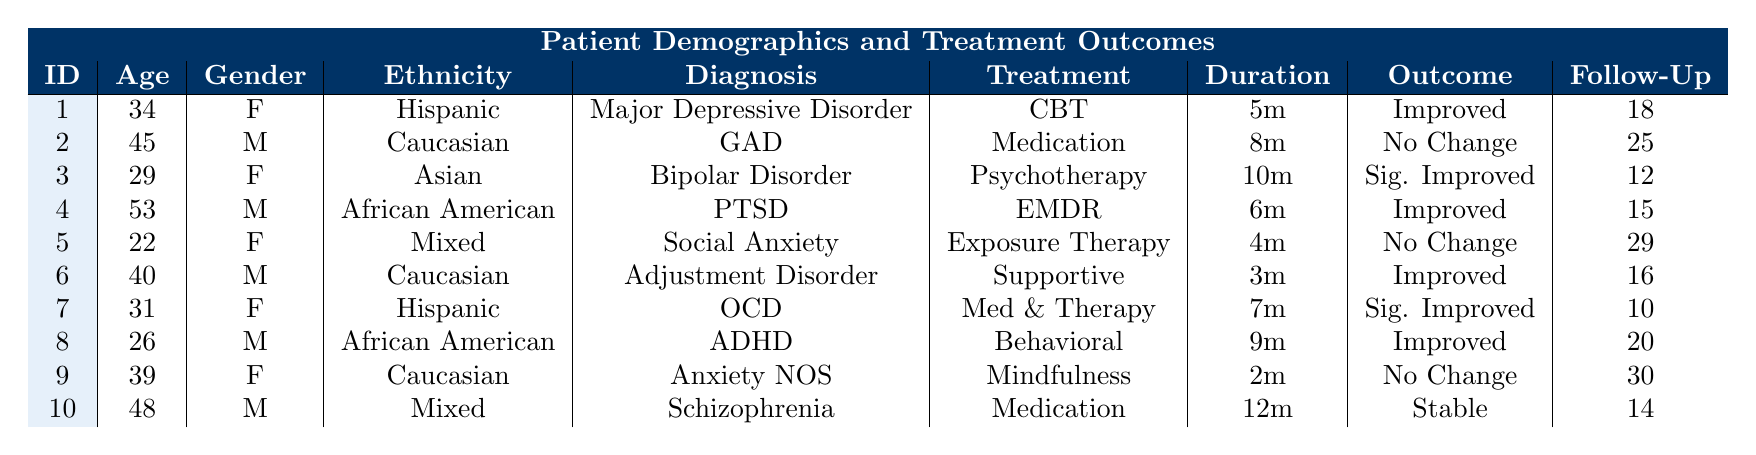What is the age of Patient 5? Patient 5's row shows that the age is listed as 22.
Answer: 22 How many patients received Medication Management as their treatment type? From the table, Patient 2 and Patient 10 are the only two patients who received Medication Management, so the total is 2.
Answer: 2 What was the Outcome of the patient diagnosed with Obsessive-Compulsive Disorder? Looking at the row for Patient 7, the Outcome is listed as "Significantly Improved."
Answer: Significantly Improved What is the Follow-Up Score for the patient who had the longest treatment duration? Patient 10, who received treatment for 12 months (longest duration), has a Follow-Up Score of 14.
Answer: 14 Which treatment types led to "Improved" outcomes? Reviewing the table, treatment types CBT (Patient 1), EMDR (Patient 4), Supportive Therapy (Patient 6), and Behavioral Therapy (Patient 8) resulted in “Improved” outcomes.
Answer: CBT, EMDR, Supportive Therapy, Behavioral Therapy Is there any patient who experienced "No Change" in their treatment outcome? Patients 2, 5, and 9 all reported "No Change" in their outcomes. Therefore, the answer is yes.
Answer: Yes What is the average Follow-Up Score of patients who had "No Change" in their treatment outcome? The Follow-Up Scores for Patients 2, 5, and 9 are 25, 29, and 30 respectively. Summing these gives 25 + 29 + 30 = 84. Dividing by 3 (the number of patients) gives an average of 28.
Answer: 28 How many patients aged 30 or younger improved their condition? Looking at the table, Patients 1 (34), 3 (29), 5 (22), and 7 (31) had improved outcomes. However, only Patient 3 and Patient 5 are aged 30 or younger. Thus, there are 2 patients who improved.
Answer: 2 Identify the demographic group with the highest incidence of "Significantly Improved" outcomes. Patient 3 and Patient 7 both showed "Significantly Improved" outcomes, where Patient 3 is Asian and Patient 7 is Hispanic. Asian and Hispanic demographics both fall in the same incidence.
Answer: Asian and Hispanic What is the overall percentage of patients who experienced "Improved" outcomes out of the total number of patients in the table? There are 10 patients total, and 5 experienced "Improved" outcomes (Patients 1, 3, 4, 6, and 8). Thus, the percentage is (5/10) * 100 = 50%.
Answer: 50% What is the difference in Follow-Up Scores between the patient with the highest and the lowest scores? The highest Follow-Up Score is 30 (Patient 9) and the lowest is 10 (Patient 7). The difference is 30 - 10 = 20.
Answer: 20 